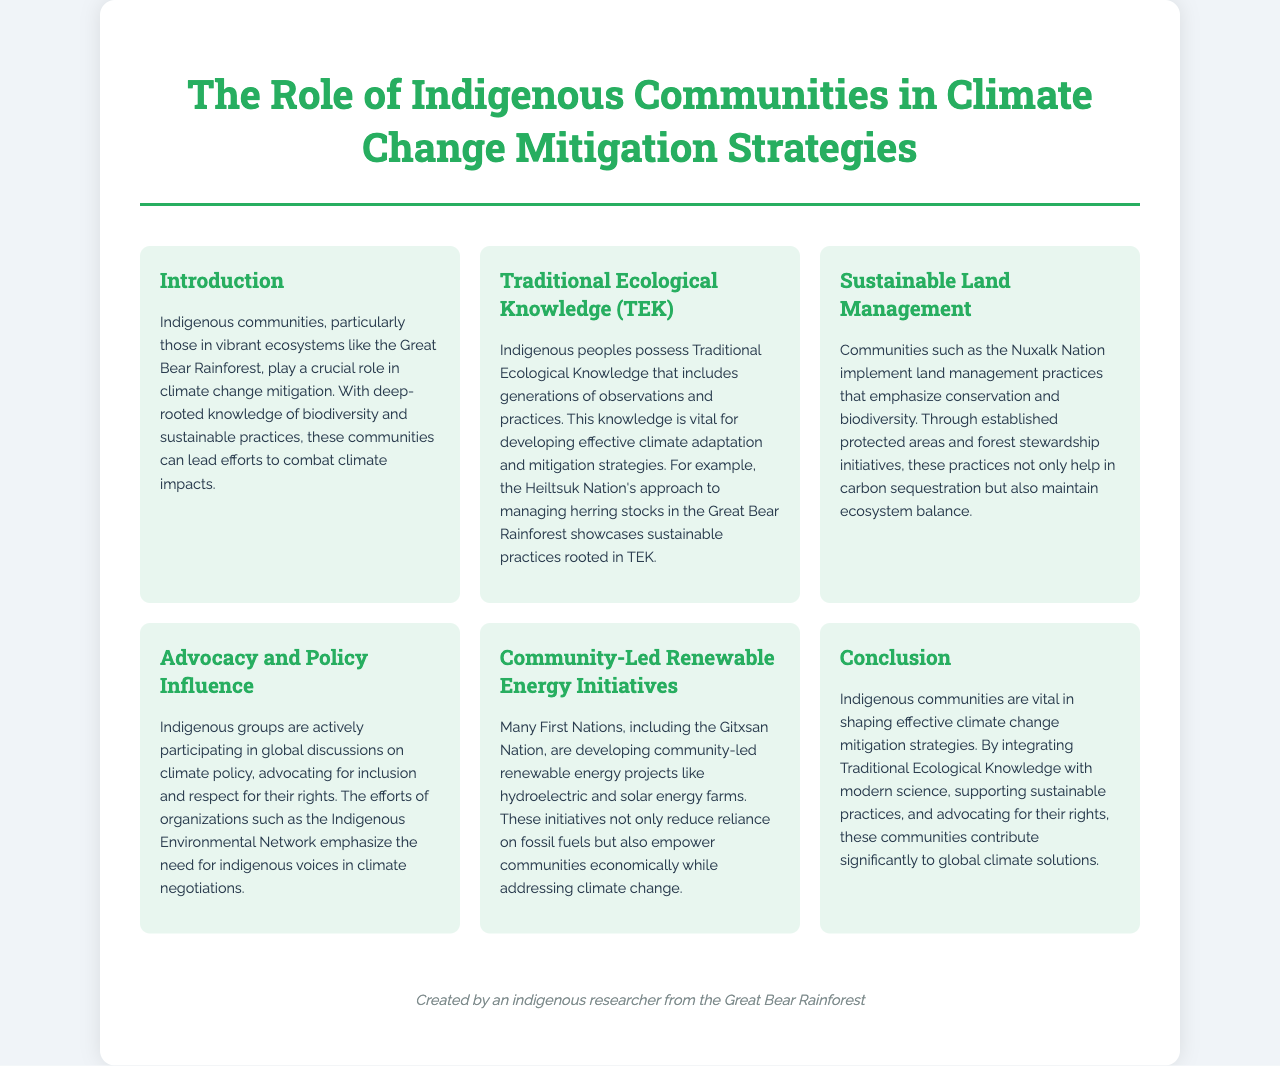What is the title of the brochure? The title of the brochure is found in the header section, where it states, "The Role of Indigenous Communities in Climate Change Mitigation Strategies."
Answer: The Role of Indigenous Communities in Climate Change Mitigation Strategies Who manages herring stocks in the Great Bear Rainforest? The document mentions the Heiltsuk Nation as an example of a community managing herring stocks, demonstrating their sustainable practices.
Answer: Heiltsuk Nation What type of energy projects are mentioned? The brochure highlights community-led renewable energy projects such as hydroelectric and solar energy farms developed by First Nations like the Gitxsan Nation.
Answer: Hydroelectric and solar energy projects What is one way that communities contribute to carbon sequestration? The section on sustainable land management explains that established protected areas and forest stewardship initiatives help in carbon sequestration.
Answer: Protected areas and forest stewardship What organization emphasizes the importance of Indigenous voices in climate negotiations? The document refers to the Indigenous Environmental Network as the organization emphasizing the need for indigenous voices in climate negotiations.
Answer: Indigenous Environmental Network 